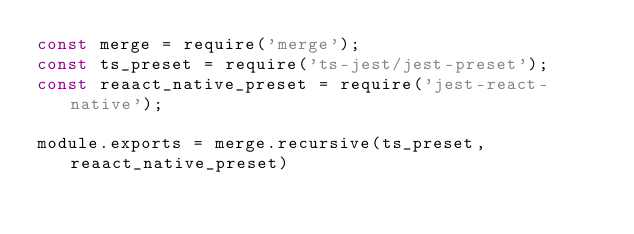Convert code to text. <code><loc_0><loc_0><loc_500><loc_500><_JavaScript_>const merge = require('merge');
const ts_preset = require('ts-jest/jest-preset');
const reaact_native_preset = require('jest-react-native');

module.exports = merge.recursive(ts_preset, reaact_native_preset)
</code> 